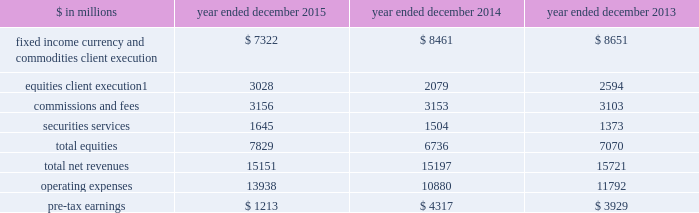The goldman sachs group , inc .
And subsidiaries management 2019s discussion and analysis equities .
Includes client execution activities related to making markets in equity products and commissions and fees from executing and clearing institutional client transactions on major stock , options and futures exchanges worldwide , as well as otc transactions .
Equities also includes our securities services business , which provides financing , securities lending and other prime brokerage services to institutional clients , including hedge funds , mutual funds , pension funds and foundations , and generates revenues primarily in the form of interest rate spreads or fees .
The table below presents the operating results of our institutional client services segment. .
Net revenues related to the americas reinsurance business were $ 317 million for 2013 .
In april 2013 , we completed the sale of a majority stake in our americas reinsurance business and no longer consolidate this business .
2015 versus 2014 .
Net revenues in institutional client services were $ 15.15 billion for 2015 , essentially unchanged compared with 2014 .
Net revenues in fixed income , currency and commodities client execution were $ 7.32 billion for 2015 , 13% ( 13 % ) lower than 2014 .
Excluding a gain of $ 168 million in 2014 related to the extinguishment of certain of our junior subordinated debt , net revenues in fixed income , currency and commodities client execution were 12% ( 12 % ) lower than 2014 , reflecting significantly lower net revenues in mortgages , credit products and commodities .
The decreases in mortgages and credit products reflected challenging market-making conditions and generally low levels of activity during 2015 .
The decline in commodities primarily reflected less favorable market-making conditions compared with 2014 , which included a strong first quarter of 2014 .
These decreases were partially offset by significantly higher net revenues in interest rate products and currencies , reflecting higher volatility levels which contributed to higher client activity levels , particularly during the first quarter of 2015 .
Net revenues in equities were $ 7.83 billion for 2015 , 16% ( 16 % ) higher than 2014 .
Excluding a gain of $ 121 million ( $ 30 million and $ 91 million included in equities client execution and securities services , respectively ) in 2014 related to the extinguishment of certain of our junior subordinated debt , net revenues in equities were 18% ( 18 % ) higher than 2014 , primarily due to significantly higher net revenues in equities client execution across the major regions , reflecting significantly higher results in both derivatives and cash products , and higher net revenues in securities services , reflecting the impact of higher average customer balances and improved securities lending spreads .
Commissions and fees were essentially unchanged compared with 2014 .
The firm elects the fair value option for certain unsecured borrowings .
The fair value net gain attributable to the impact of changes in our credit spreads on these borrowings was $ 255 million ( $ 214 million and $ 41 million related to fixed income , currency and commodities client execution and equities client execution , respectively ) for 2015 , compared with a net gain of $ 144 million ( $ 108 million and $ 36 million related to fixed income , currency and commodities client execution and equities client execution , respectively ) for 2014 .
During 2015 , the operating environment for institutional client services was positively impacted by diverging central bank monetary policies in the united states and the euro area in the first quarter , as increased volatility levels contributed to strong client activity levels in currencies , interest rate products and equity products , and market- making conditions improved .
However , during the remainder of the year , concerns about global growth and uncertainty about the u.s .
Federal reserve 2019s interest rate policy , along with lower global equity prices , widening high-yield credit spreads and declining commodity prices , contributed to lower levels of client activity , particularly in mortgages and credit , and more difficult market-making conditions .
If macroeconomic concerns continue over the long term and activity levels decline , net revenues in institutional client services would likely be negatively impacted .
Operating expenses were $ 13.94 billion for 2015 , 28% ( 28 % ) higher than 2014 , due to significantly higher net provisions for mortgage-related litigation and regulatory matters , partially offset by decreased compensation and benefits expenses .
Pre-tax earnings were $ 1.21 billion in 2015 , 72% ( 72 % ) lower than 2014 .
62 goldman sachs 2015 form 10-k .
In millions for 2015 , 2014 , and 2013 , what was the lowest amount of commissions and fees? 
Computations: table_min(commissions and fees, none)
Answer: 3103.0. 